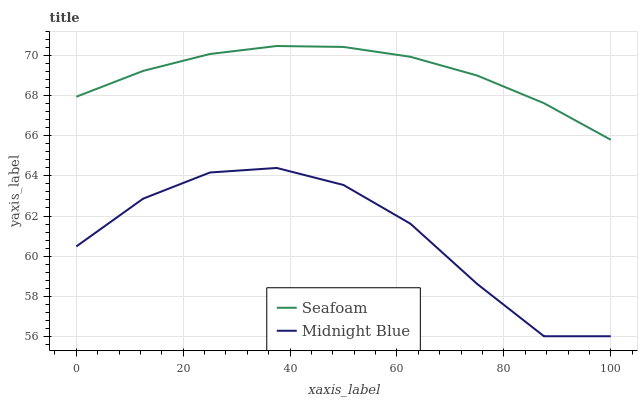Does Midnight Blue have the minimum area under the curve?
Answer yes or no. Yes. Does Seafoam have the maximum area under the curve?
Answer yes or no. Yes. Does Midnight Blue have the maximum area under the curve?
Answer yes or no. No. Is Seafoam the smoothest?
Answer yes or no. Yes. Is Midnight Blue the roughest?
Answer yes or no. Yes. Is Midnight Blue the smoothest?
Answer yes or no. No. Does Midnight Blue have the lowest value?
Answer yes or no. Yes. Does Seafoam have the highest value?
Answer yes or no. Yes. Does Midnight Blue have the highest value?
Answer yes or no. No. Is Midnight Blue less than Seafoam?
Answer yes or no. Yes. Is Seafoam greater than Midnight Blue?
Answer yes or no. Yes. Does Midnight Blue intersect Seafoam?
Answer yes or no. No. 